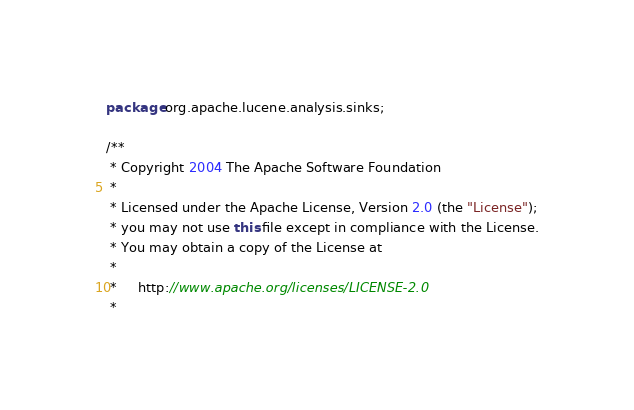Convert code to text. <code><loc_0><loc_0><loc_500><loc_500><_Java_>package org.apache.lucene.analysis.sinks;

/**
 * Copyright 2004 The Apache Software Foundation
 *
 * Licensed under the Apache License, Version 2.0 (the "License");
 * you may not use this file except in compliance with the License.
 * You may obtain a copy of the License at
 *
 *     http://www.apache.org/licenses/LICENSE-2.0
 *</code> 